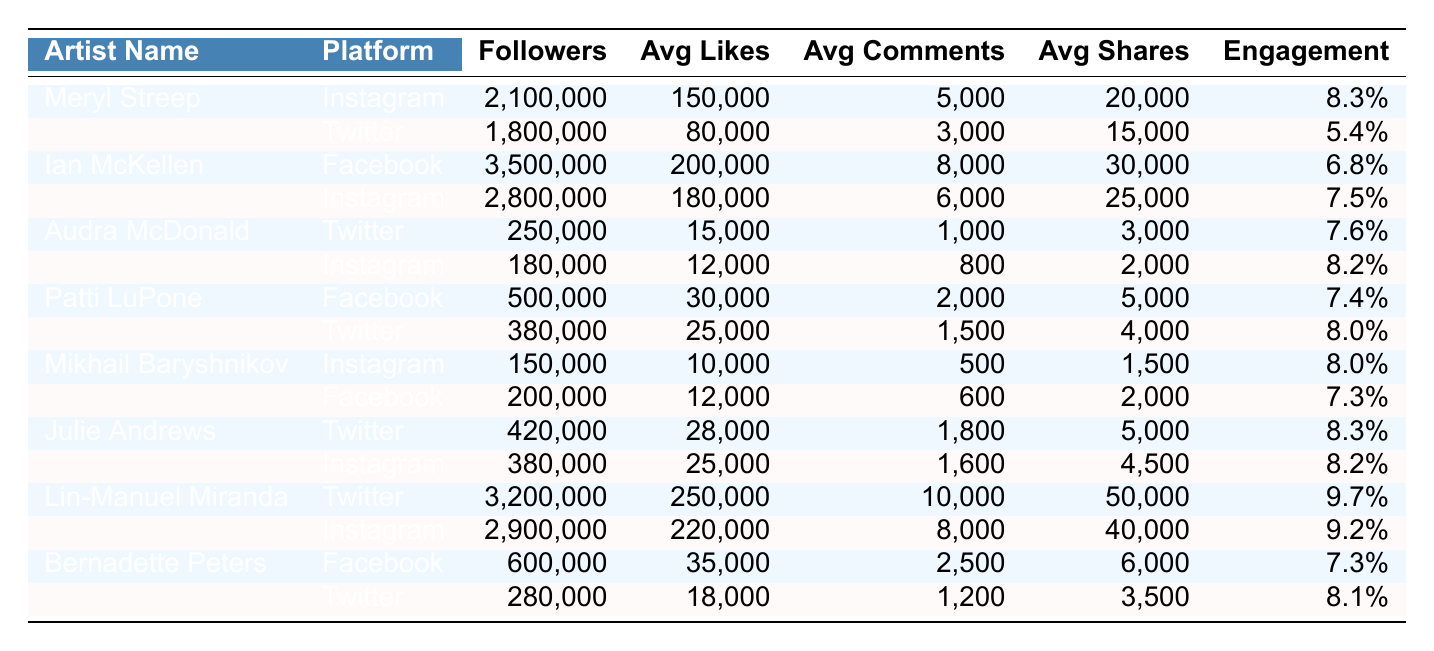What is the highest engagement rate among the artists listed? By examining the engagement rates in the table, I find that Lin-Manuel Miranda has the highest engagement rate at 9.7%.
Answer: 9.7% Which platform does Meryl Streep have the most followers on? Meryl Streep has 2,100,000 followers on Instagram, which is higher than 1,800,000 followers on Twitter.
Answer: Instagram What is the average number of likes for Ian McKellen across both platforms? Ian McKellen has an average of 200,000 likes on Facebook and 180,000 likes on Instagram. The total likes combined is 200,000 + 180,000 = 380,000. Dividing this by 2 gives an average of 190,000 likes.
Answer: 190,000 Does Audra McDonald have a higher average share count on Instagram or Twitter? On Instagram, Audra McDonald has an average of 2,000 shares, while on Twitter, she has 3,000 shares. Since 3,000 is greater than 2,000, she has a higher count on Twitter.
Answer: Yes What is the total number of followers for all artists on Facebook? Adding the followers for each artist on Facebook: Ian McKellen (3,500,000) + Patti LuPone (500,000) + Mikhail Baryshnikov (200,000) + Bernadette Peters (600,000) gives a total of 4,800,000 followers.
Answer: 4,800,000 Which artist has the smallest average comment count? Checking the average comments, I see Mikhail Baryshnikov has the smallest count of 500 on Instagram, which is less than Audra McDonald's on Twitter (1,000).
Answer: Mikhail Baryshnikov How does the engagement rate for Lin-Manuel Miranda on Instagram compare to that on Twitter? Lin-Manuel Miranda has an engagement rate of 9.2% on Instagram and 9.7% on Twitter, indicating that the rate is higher on Twitter.
Answer: Higher on Twitter What is the difference in average likes between Julie Andrews on Twitter and Instagram? Julie Andrews averages 28,000 likes on Twitter and 25,000 likes on Instagram. The difference is 28,000 - 25,000 = 3,000.
Answer: 3,000 Are the average shares for Bernadette Peters higher on Facebook or Twitter? Bernadette Peters averages 6,000 shares on Facebook and 3,500 shares on Twitter. Since 6,000 is greater than 3,500, her shares are higher on Facebook.
Answer: Facebook Which platform has the most total followers across all artists listed in the table? From the followers listed, Instagram totals: 2,100,000 + 2,800,000 + 180,000 + 380,000 + 2,900,000 = 8,380,000 followers, compared to Twitter and Facebook, making Instagram the highest.
Answer: Instagram 